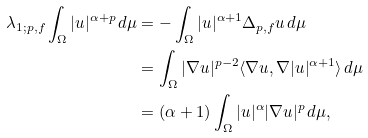<formula> <loc_0><loc_0><loc_500><loc_500>\lambda _ { 1 ; p , f } \int _ { \Omega } | u | ^ { \alpha + p } \, d \mu & = - \int _ { \Omega } | u | ^ { \alpha + 1 } \Delta _ { p , f } u \, d \mu \\ & = \int _ { \Omega } | \nabla u | ^ { p - 2 } \langle \nabla u , \nabla | u | ^ { \alpha + 1 } \rangle \, d \mu \\ & = ( \alpha + 1 ) \int _ { \Omega } | u | ^ { \alpha } | \nabla u | ^ { p } \, d \mu ,</formula> 